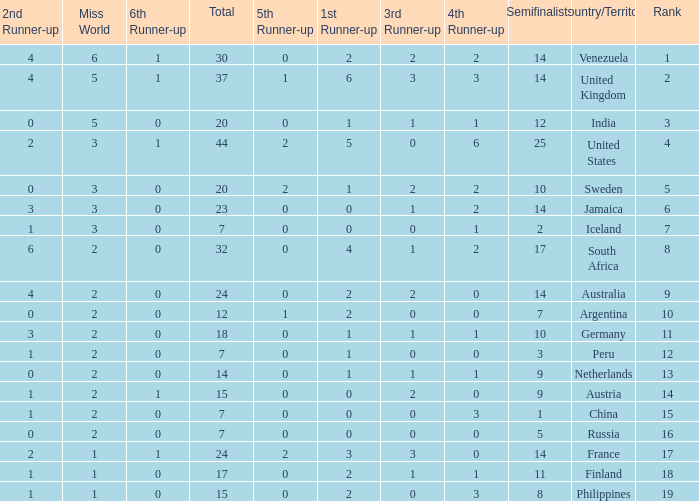Which countries have a 5th runner-up ranking is 2 and the 3rd runner-up ranking is 0 44.0. 